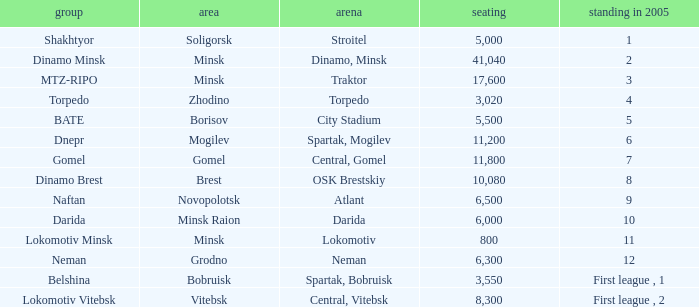Can you tell me the Capacity that has the Position in 2005 of 8? 10080.0. 